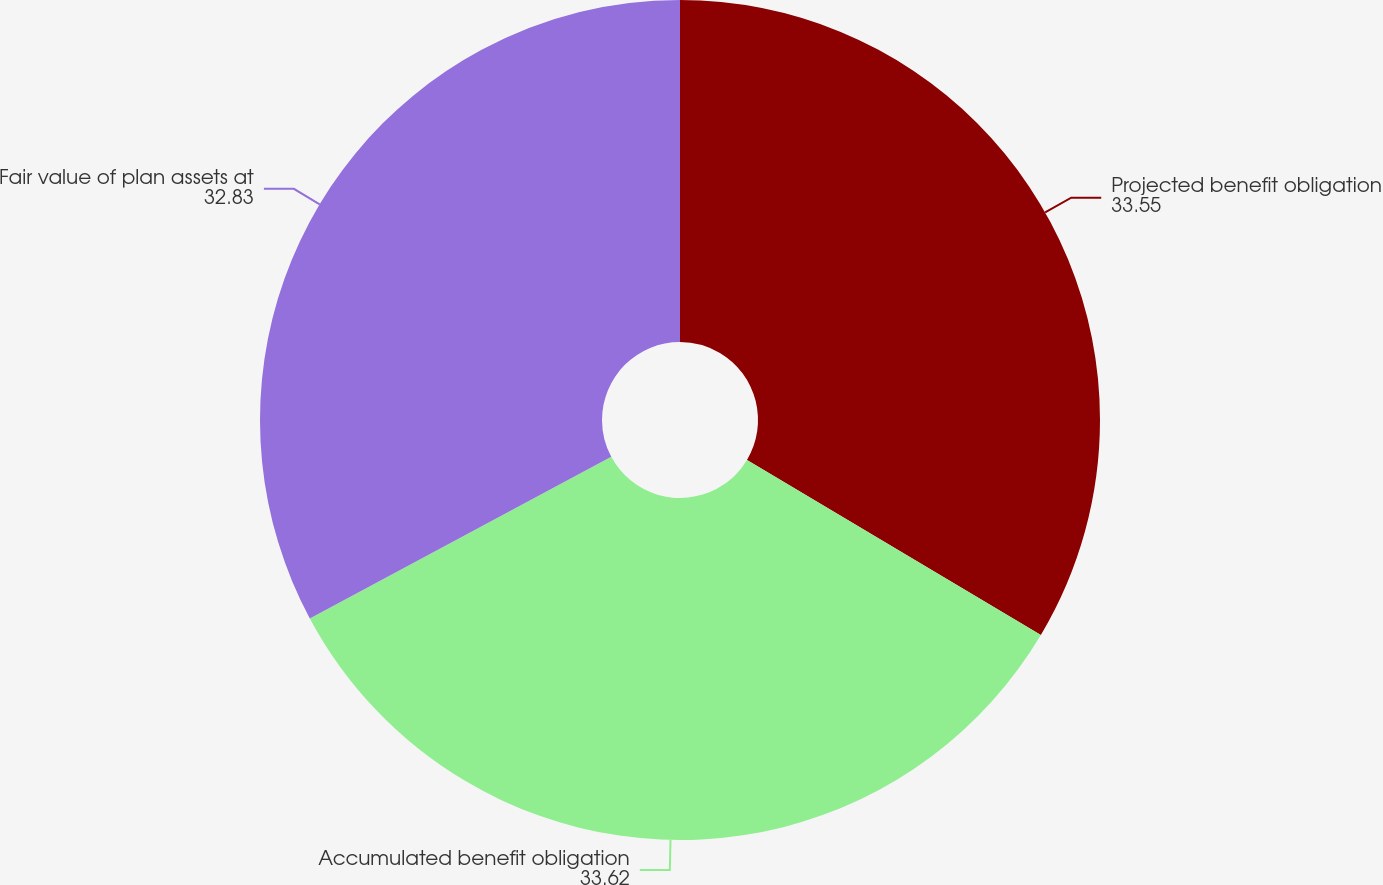Convert chart to OTSL. <chart><loc_0><loc_0><loc_500><loc_500><pie_chart><fcel>Projected benefit obligation<fcel>Accumulated benefit obligation<fcel>Fair value of plan assets at<nl><fcel>33.55%<fcel>33.62%<fcel>32.83%<nl></chart> 